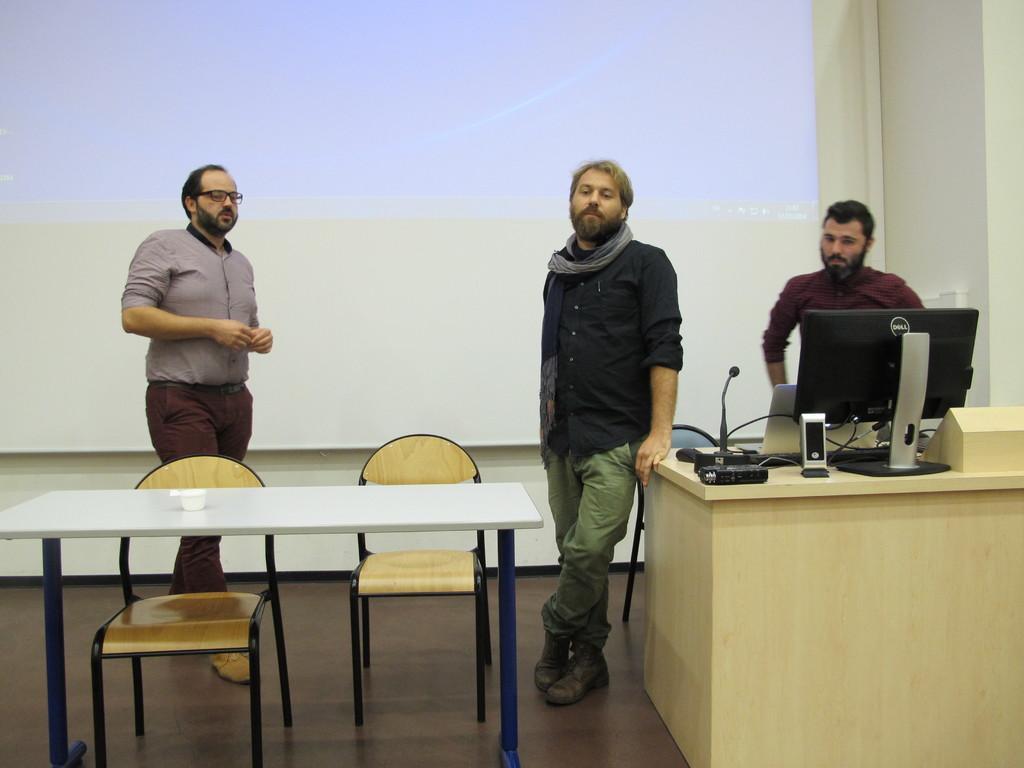Describe this image in one or two sentences. There are three men standing. There is a table. On the table there is a system, and a mic and a laptop. At the back there is a screen. On the white table there is a cup. And we can also see two chairs. 